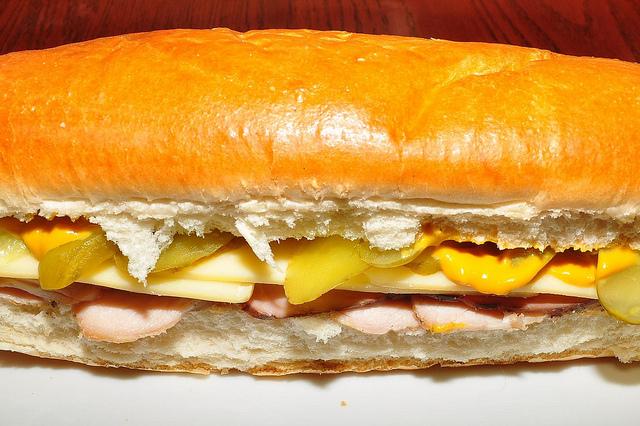Has any of this food been eaten?
Write a very short answer. No. What color is the cheese on the sandwich?
Write a very short answer. White. Is there cheese on this sandwich?
Keep it brief. Yes. 